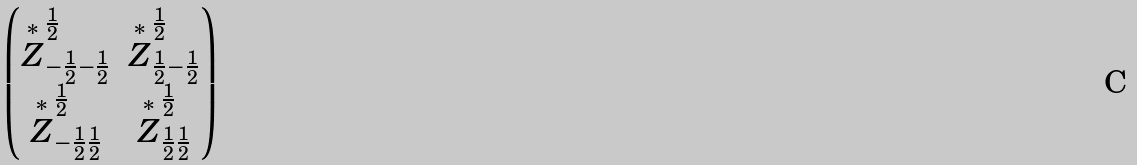Convert formula to latex. <formula><loc_0><loc_0><loc_500><loc_500>\begin{pmatrix} \overset { \ast } { Z } ^ { \frac { 1 } { 2 } } _ { - \frac { 1 } { 2 } - \frac { 1 } { 2 } } & \overset { \ast } { Z } ^ { \frac { 1 } { 2 } } _ { \frac { 1 } { 2 } - \frac { 1 } { 2 } } \\ \overset { \ast } { Z } ^ { \frac { 1 } { 2 } } _ { - \frac { 1 } { 2 } \frac { 1 } { 2 } } & \overset { \ast } { Z } ^ { \frac { 1 } { 2 } } _ { \frac { 1 } { 2 } \frac { 1 } { 2 } } \end{pmatrix}</formula> 